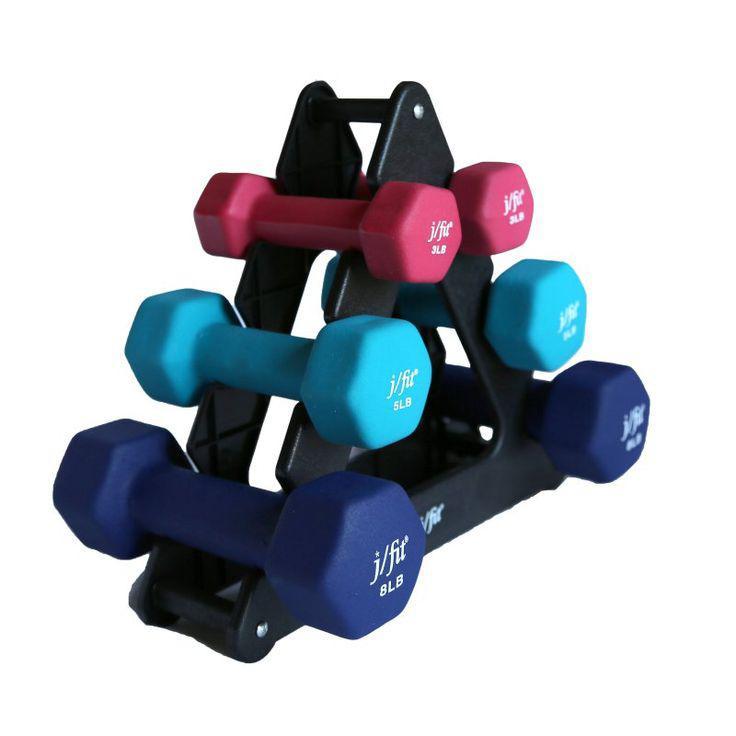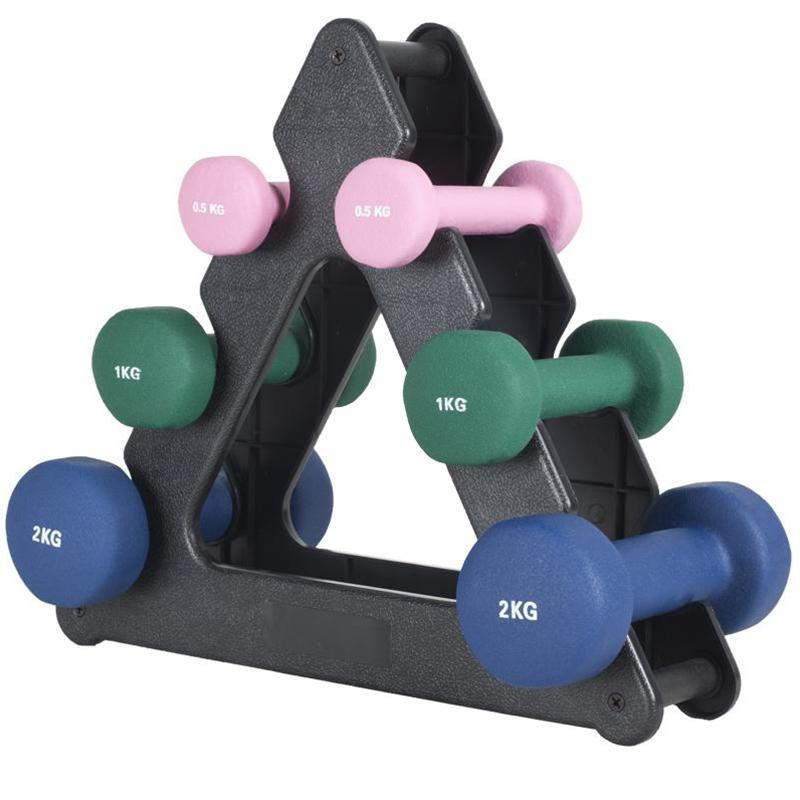The first image is the image on the left, the second image is the image on the right. Examine the images to the left and right. Is the description "In each image, three pairs of dumbbells, each a different color, at stacked on a triangular shaped rack with a pink pair in the uppermost position." accurate? Answer yes or no. Yes. 